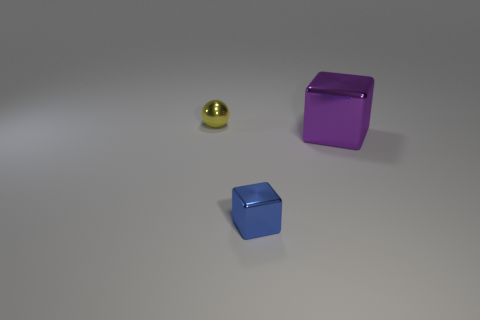Is the number of metallic things greater than the number of small blue metal cubes?
Make the answer very short. Yes. Do the purple thing and the yellow metal sphere have the same size?
Ensure brevity in your answer.  No. What number of objects are tiny blue shiny things or metal balls?
Provide a short and direct response. 2. There is a thing that is behind the cube on the right side of the block to the left of the big shiny thing; what is its shape?
Keep it short and to the point. Sphere. Are the tiny object in front of the yellow shiny sphere and the small object behind the purple thing made of the same material?
Your answer should be very brief. Yes. There is a tiny thing that is the same shape as the large thing; what is its material?
Your answer should be compact. Metal. Is there any other thing that has the same size as the purple object?
Ensure brevity in your answer.  No. There is a tiny thing that is in front of the big shiny cube; does it have the same shape as the shiny object that is behind the large block?
Your response must be concise. No. Is the number of purple shiny cubes left of the small blue shiny thing less than the number of purple metallic things that are behind the large metallic thing?
Provide a short and direct response. No. How many other objects are the same shape as the tiny blue shiny thing?
Offer a very short reply. 1. 